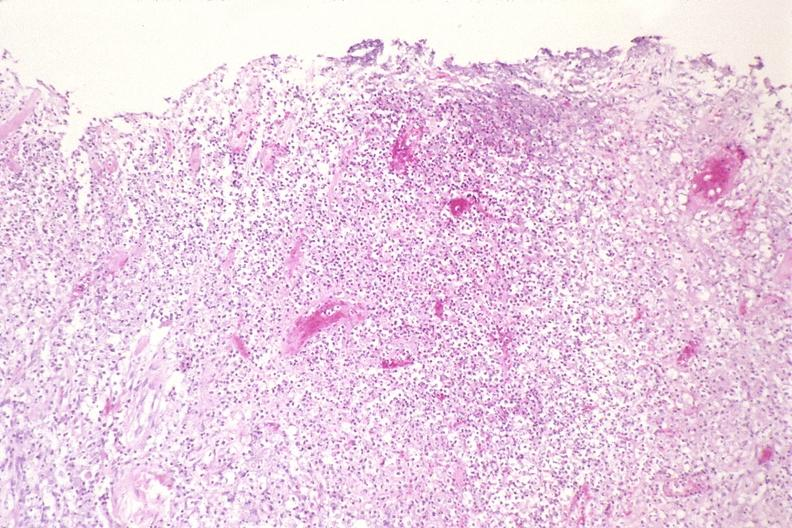what does this image show?
Answer the question using a single word or phrase. Lung 